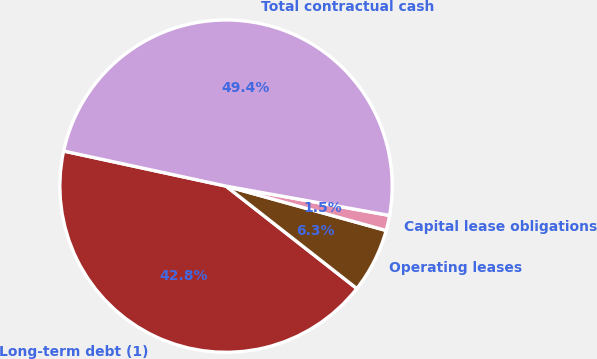Convert chart. <chart><loc_0><loc_0><loc_500><loc_500><pie_chart><fcel>Long-term debt (1)<fcel>Operating leases<fcel>Capital lease obligations<fcel>Total contractual cash<nl><fcel>42.82%<fcel>6.27%<fcel>1.48%<fcel>49.44%<nl></chart> 